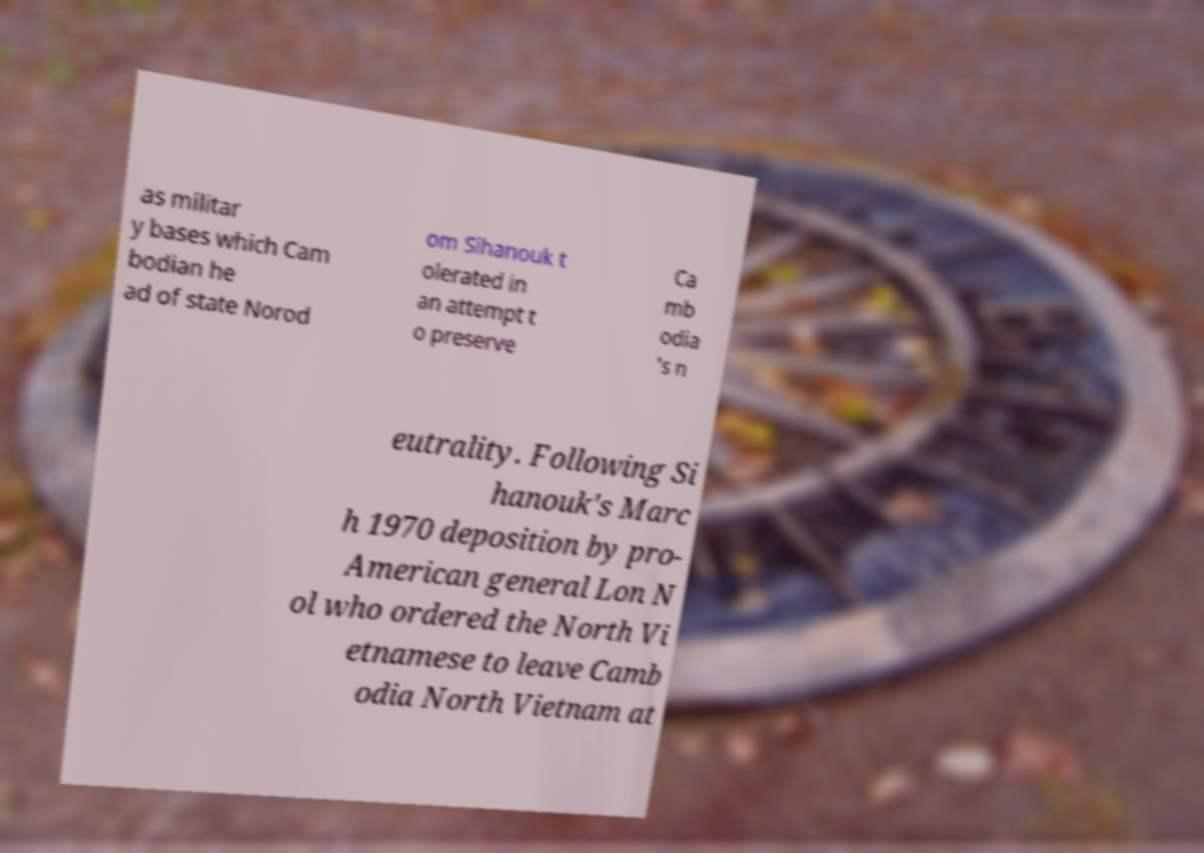Could you assist in decoding the text presented in this image and type it out clearly? as militar y bases which Cam bodian he ad of state Norod om Sihanouk t olerated in an attempt t o preserve Ca mb odia 's n eutrality. Following Si hanouk's Marc h 1970 deposition by pro- American general Lon N ol who ordered the North Vi etnamese to leave Camb odia North Vietnam at 